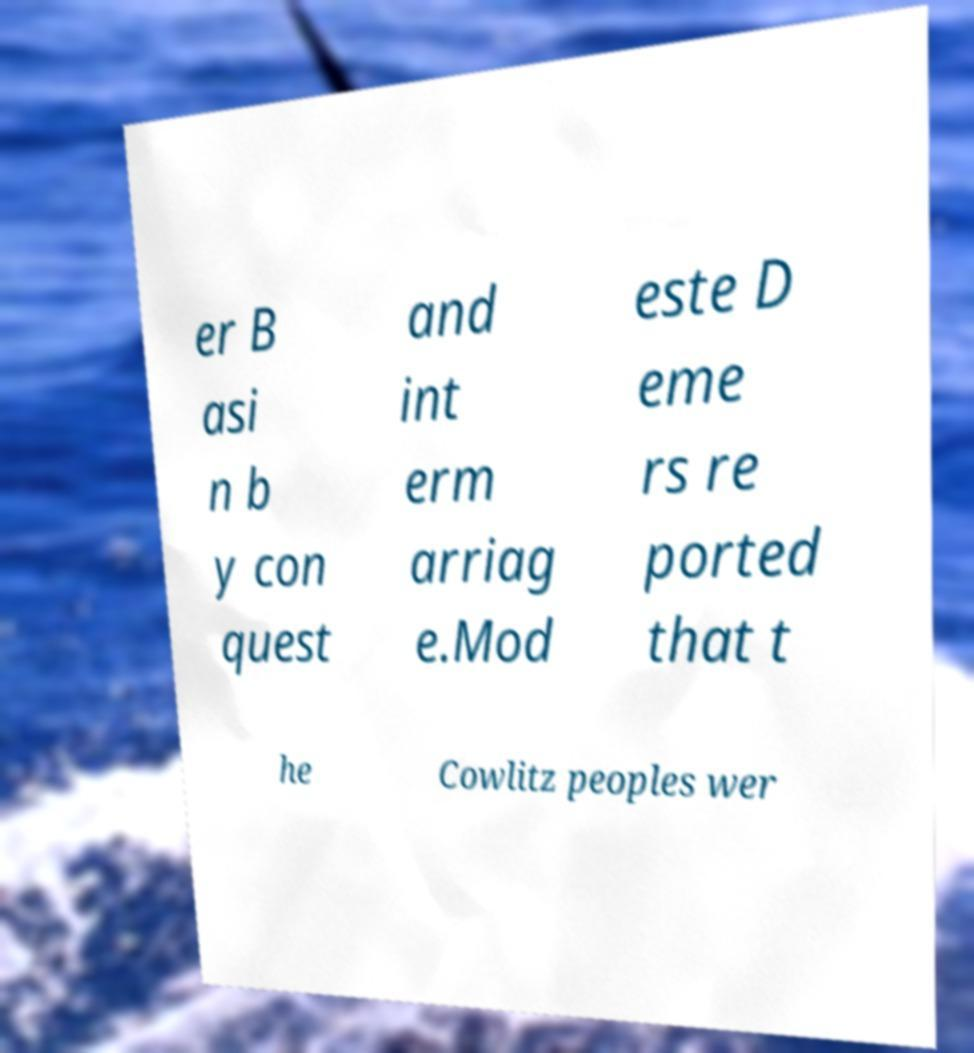Please read and relay the text visible in this image. What does it say? er B asi n b y con quest and int erm arriag e.Mod este D eme rs re ported that t he Cowlitz peoples wer 